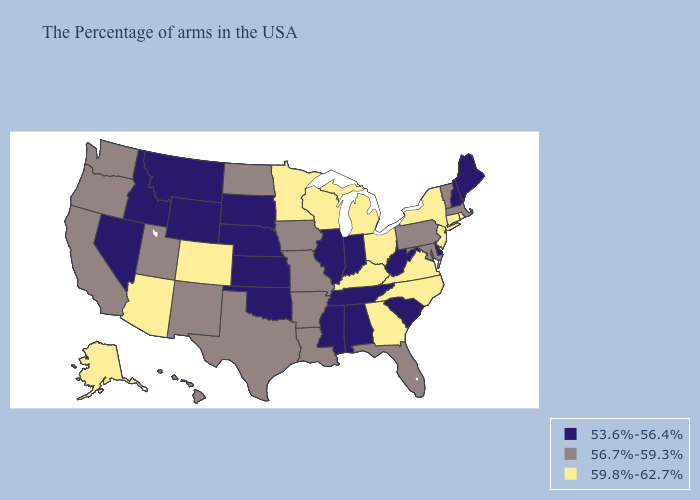Name the states that have a value in the range 59.8%-62.7%?
Keep it brief. Rhode Island, Connecticut, New York, New Jersey, Virginia, North Carolina, Ohio, Georgia, Michigan, Kentucky, Wisconsin, Minnesota, Colorado, Arizona, Alaska. Name the states that have a value in the range 59.8%-62.7%?
Be succinct. Rhode Island, Connecticut, New York, New Jersey, Virginia, North Carolina, Ohio, Georgia, Michigan, Kentucky, Wisconsin, Minnesota, Colorado, Arizona, Alaska. Which states have the lowest value in the USA?
Write a very short answer. Maine, New Hampshire, Delaware, South Carolina, West Virginia, Indiana, Alabama, Tennessee, Illinois, Mississippi, Kansas, Nebraska, Oklahoma, South Dakota, Wyoming, Montana, Idaho, Nevada. Does Mississippi have a lower value than Oklahoma?
Quick response, please. No. Name the states that have a value in the range 56.7%-59.3%?
Answer briefly. Massachusetts, Vermont, Maryland, Pennsylvania, Florida, Louisiana, Missouri, Arkansas, Iowa, Texas, North Dakota, New Mexico, Utah, California, Washington, Oregon, Hawaii. Among the states that border Maryland , which have the highest value?
Write a very short answer. Virginia. Name the states that have a value in the range 56.7%-59.3%?
Give a very brief answer. Massachusetts, Vermont, Maryland, Pennsylvania, Florida, Louisiana, Missouri, Arkansas, Iowa, Texas, North Dakota, New Mexico, Utah, California, Washington, Oregon, Hawaii. How many symbols are there in the legend?
Quick response, please. 3. Name the states that have a value in the range 59.8%-62.7%?
Short answer required. Rhode Island, Connecticut, New York, New Jersey, Virginia, North Carolina, Ohio, Georgia, Michigan, Kentucky, Wisconsin, Minnesota, Colorado, Arizona, Alaska. Among the states that border Mississippi , does Alabama have the lowest value?
Answer briefly. Yes. Name the states that have a value in the range 59.8%-62.7%?
Keep it brief. Rhode Island, Connecticut, New York, New Jersey, Virginia, North Carolina, Ohio, Georgia, Michigan, Kentucky, Wisconsin, Minnesota, Colorado, Arizona, Alaska. Name the states that have a value in the range 59.8%-62.7%?
Be succinct. Rhode Island, Connecticut, New York, New Jersey, Virginia, North Carolina, Ohio, Georgia, Michigan, Kentucky, Wisconsin, Minnesota, Colorado, Arizona, Alaska. Name the states that have a value in the range 59.8%-62.7%?
Keep it brief. Rhode Island, Connecticut, New York, New Jersey, Virginia, North Carolina, Ohio, Georgia, Michigan, Kentucky, Wisconsin, Minnesota, Colorado, Arizona, Alaska. Name the states that have a value in the range 56.7%-59.3%?
Be succinct. Massachusetts, Vermont, Maryland, Pennsylvania, Florida, Louisiana, Missouri, Arkansas, Iowa, Texas, North Dakota, New Mexico, Utah, California, Washington, Oregon, Hawaii. Among the states that border Arkansas , which have the highest value?
Quick response, please. Louisiana, Missouri, Texas. 